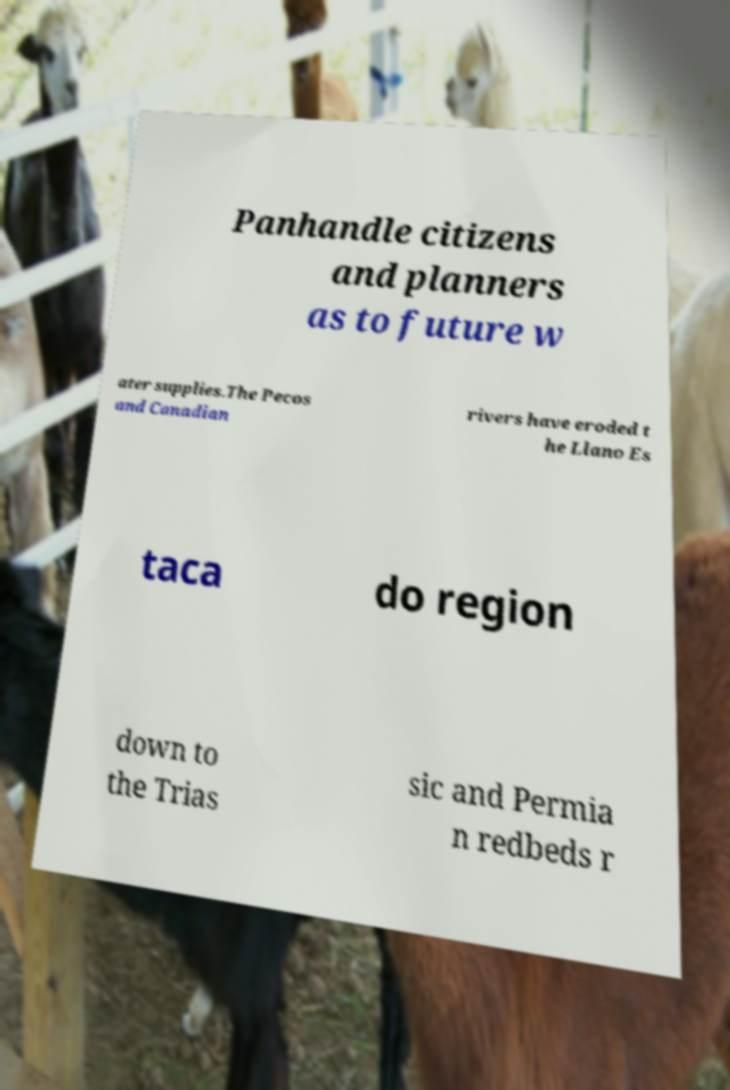For documentation purposes, I need the text within this image transcribed. Could you provide that? Panhandle citizens and planners as to future w ater supplies.The Pecos and Canadian rivers have eroded t he Llano Es taca do region down to the Trias sic and Permia n redbeds r 